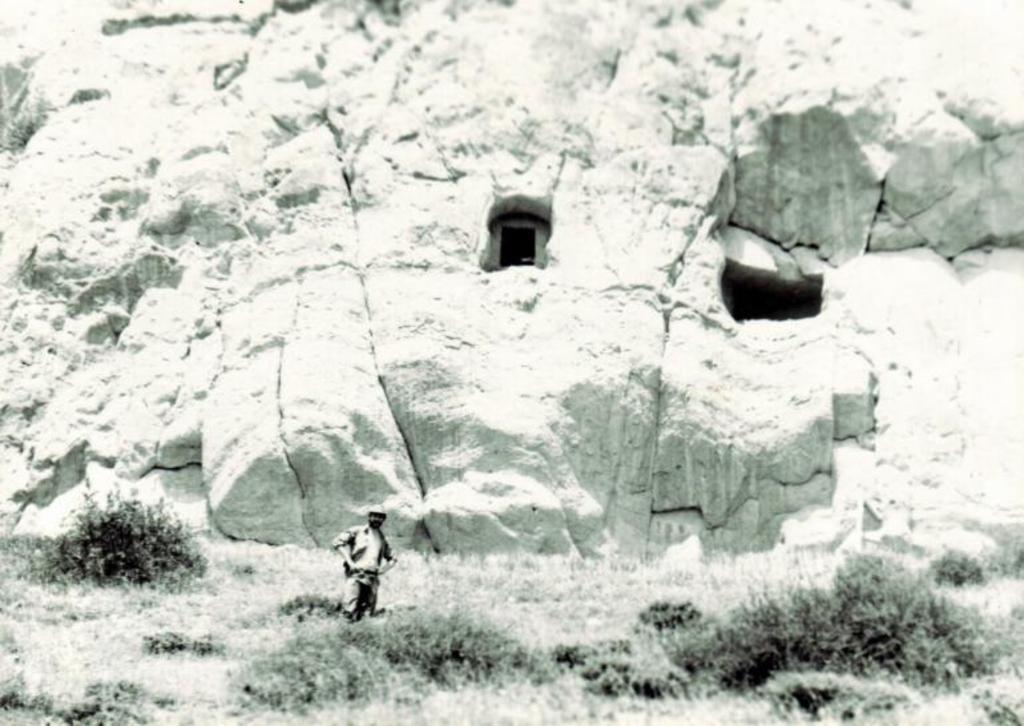Who or what is present in the image? There is a person in the image. What is the person's position in relation to the surroundings? The person is standing in the grass. What can be seen in the background of the image? There is a huge hill behind the person. What type of tomatoes are being discussed by the committee in the image? There is no committee or tomatoes present in the image; it features a person standing in the grass with a hill in the background. 